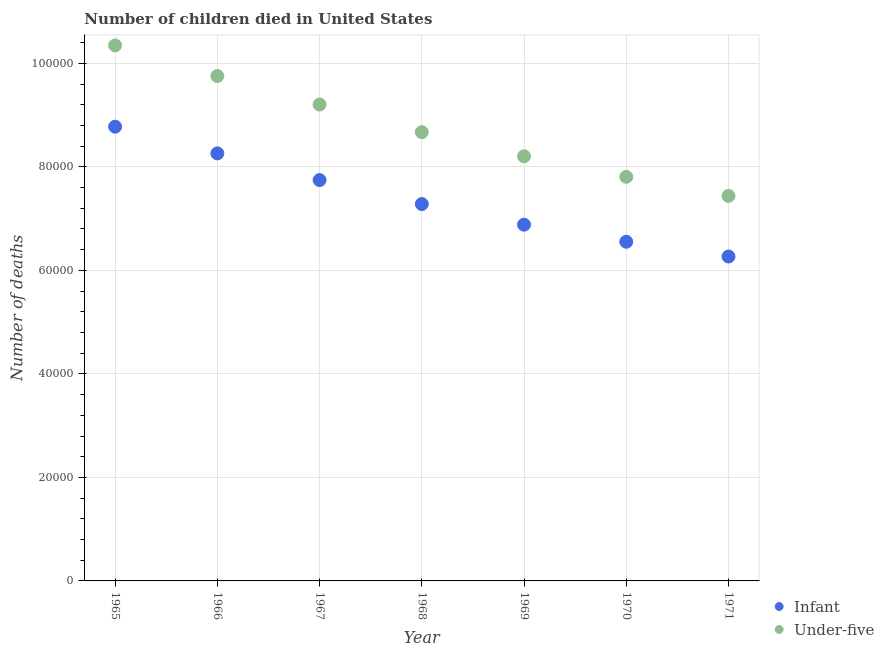What is the number of under-five deaths in 1968?
Keep it short and to the point. 8.67e+04. Across all years, what is the maximum number of infant deaths?
Offer a very short reply. 8.78e+04. Across all years, what is the minimum number of infant deaths?
Keep it short and to the point. 6.27e+04. In which year was the number of infant deaths maximum?
Give a very brief answer. 1965. What is the total number of infant deaths in the graph?
Your answer should be very brief. 5.18e+05. What is the difference between the number of infant deaths in 1965 and that in 1971?
Offer a terse response. 2.51e+04. What is the difference between the number of infant deaths in 1967 and the number of under-five deaths in 1970?
Give a very brief answer. -627. What is the average number of under-five deaths per year?
Provide a short and direct response. 8.78e+04. In the year 1968, what is the difference between the number of under-five deaths and number of infant deaths?
Provide a short and direct response. 1.39e+04. In how many years, is the number of under-five deaths greater than 68000?
Provide a short and direct response. 7. What is the ratio of the number of infant deaths in 1968 to that in 1970?
Offer a terse response. 1.11. Is the difference between the number of infant deaths in 1967 and 1968 greater than the difference between the number of under-five deaths in 1967 and 1968?
Your answer should be compact. No. What is the difference between the highest and the second highest number of infant deaths?
Provide a succinct answer. 5159. What is the difference between the highest and the lowest number of infant deaths?
Give a very brief answer. 2.51e+04. In how many years, is the number of infant deaths greater than the average number of infant deaths taken over all years?
Provide a succinct answer. 3. Is the sum of the number of under-five deaths in 1965 and 1966 greater than the maximum number of infant deaths across all years?
Provide a succinct answer. Yes. What is the difference between two consecutive major ticks on the Y-axis?
Make the answer very short. 2.00e+04. Are the values on the major ticks of Y-axis written in scientific E-notation?
Provide a succinct answer. No. Does the graph contain any zero values?
Your answer should be compact. No. How many legend labels are there?
Offer a terse response. 2. How are the legend labels stacked?
Offer a very short reply. Vertical. What is the title of the graph?
Make the answer very short. Number of children died in United States. Does "National Visitors" appear as one of the legend labels in the graph?
Give a very brief answer. No. What is the label or title of the Y-axis?
Your response must be concise. Number of deaths. What is the Number of deaths in Infant in 1965?
Offer a very short reply. 8.78e+04. What is the Number of deaths in Under-five in 1965?
Your response must be concise. 1.03e+05. What is the Number of deaths in Infant in 1966?
Ensure brevity in your answer.  8.26e+04. What is the Number of deaths of Under-five in 1966?
Your answer should be very brief. 9.75e+04. What is the Number of deaths of Infant in 1967?
Give a very brief answer. 7.74e+04. What is the Number of deaths of Under-five in 1967?
Provide a succinct answer. 9.20e+04. What is the Number of deaths in Infant in 1968?
Provide a succinct answer. 7.28e+04. What is the Number of deaths of Under-five in 1968?
Provide a short and direct response. 8.67e+04. What is the Number of deaths in Infant in 1969?
Your answer should be compact. 6.88e+04. What is the Number of deaths in Under-five in 1969?
Offer a terse response. 8.20e+04. What is the Number of deaths of Infant in 1970?
Your response must be concise. 6.55e+04. What is the Number of deaths in Under-five in 1970?
Make the answer very short. 7.81e+04. What is the Number of deaths of Infant in 1971?
Keep it short and to the point. 6.27e+04. What is the Number of deaths in Under-five in 1971?
Offer a very short reply. 7.44e+04. Across all years, what is the maximum Number of deaths of Infant?
Offer a very short reply. 8.78e+04. Across all years, what is the maximum Number of deaths in Under-five?
Ensure brevity in your answer.  1.03e+05. Across all years, what is the minimum Number of deaths in Infant?
Provide a short and direct response. 6.27e+04. Across all years, what is the minimum Number of deaths of Under-five?
Keep it short and to the point. 7.44e+04. What is the total Number of deaths of Infant in the graph?
Provide a succinct answer. 5.18e+05. What is the total Number of deaths of Under-five in the graph?
Keep it short and to the point. 6.14e+05. What is the difference between the Number of deaths of Infant in 1965 and that in 1966?
Offer a terse response. 5159. What is the difference between the Number of deaths of Under-five in 1965 and that in 1966?
Offer a terse response. 5917. What is the difference between the Number of deaths in Infant in 1965 and that in 1967?
Make the answer very short. 1.03e+04. What is the difference between the Number of deaths of Under-five in 1965 and that in 1967?
Keep it short and to the point. 1.14e+04. What is the difference between the Number of deaths in Infant in 1965 and that in 1968?
Your answer should be compact. 1.49e+04. What is the difference between the Number of deaths of Under-five in 1965 and that in 1968?
Your response must be concise. 1.68e+04. What is the difference between the Number of deaths in Infant in 1965 and that in 1969?
Your answer should be compact. 1.89e+04. What is the difference between the Number of deaths in Under-five in 1965 and that in 1969?
Provide a succinct answer. 2.14e+04. What is the difference between the Number of deaths of Infant in 1965 and that in 1970?
Keep it short and to the point. 2.22e+04. What is the difference between the Number of deaths of Under-five in 1965 and that in 1970?
Provide a succinct answer. 2.54e+04. What is the difference between the Number of deaths of Infant in 1965 and that in 1971?
Give a very brief answer. 2.51e+04. What is the difference between the Number of deaths of Under-five in 1965 and that in 1971?
Your answer should be compact. 2.91e+04. What is the difference between the Number of deaths in Infant in 1966 and that in 1967?
Provide a succinct answer. 5157. What is the difference between the Number of deaths in Under-five in 1966 and that in 1967?
Offer a terse response. 5499. What is the difference between the Number of deaths of Infant in 1966 and that in 1968?
Give a very brief answer. 9789. What is the difference between the Number of deaths of Under-five in 1966 and that in 1968?
Provide a succinct answer. 1.08e+04. What is the difference between the Number of deaths of Infant in 1966 and that in 1969?
Keep it short and to the point. 1.38e+04. What is the difference between the Number of deaths of Under-five in 1966 and that in 1969?
Your answer should be very brief. 1.55e+04. What is the difference between the Number of deaths in Infant in 1966 and that in 1970?
Your answer should be compact. 1.71e+04. What is the difference between the Number of deaths of Under-five in 1966 and that in 1970?
Provide a short and direct response. 1.95e+04. What is the difference between the Number of deaths in Infant in 1966 and that in 1971?
Provide a succinct answer. 1.99e+04. What is the difference between the Number of deaths in Under-five in 1966 and that in 1971?
Provide a short and direct response. 2.32e+04. What is the difference between the Number of deaths in Infant in 1967 and that in 1968?
Offer a terse response. 4632. What is the difference between the Number of deaths in Under-five in 1967 and that in 1968?
Offer a very short reply. 5339. What is the difference between the Number of deaths in Infant in 1967 and that in 1969?
Offer a terse response. 8618. What is the difference between the Number of deaths in Under-five in 1967 and that in 1969?
Your answer should be compact. 1.00e+04. What is the difference between the Number of deaths in Infant in 1967 and that in 1970?
Give a very brief answer. 1.19e+04. What is the difference between the Number of deaths in Under-five in 1967 and that in 1970?
Offer a very short reply. 1.40e+04. What is the difference between the Number of deaths in Infant in 1967 and that in 1971?
Ensure brevity in your answer.  1.48e+04. What is the difference between the Number of deaths in Under-five in 1967 and that in 1971?
Provide a succinct answer. 1.77e+04. What is the difference between the Number of deaths in Infant in 1968 and that in 1969?
Your answer should be very brief. 3986. What is the difference between the Number of deaths in Under-five in 1968 and that in 1969?
Make the answer very short. 4663. What is the difference between the Number of deaths of Infant in 1968 and that in 1970?
Provide a short and direct response. 7285. What is the difference between the Number of deaths of Under-five in 1968 and that in 1970?
Your response must be concise. 8634. What is the difference between the Number of deaths of Infant in 1968 and that in 1971?
Your response must be concise. 1.01e+04. What is the difference between the Number of deaths in Under-five in 1968 and that in 1971?
Provide a short and direct response. 1.23e+04. What is the difference between the Number of deaths in Infant in 1969 and that in 1970?
Give a very brief answer. 3299. What is the difference between the Number of deaths in Under-five in 1969 and that in 1970?
Keep it short and to the point. 3971. What is the difference between the Number of deaths in Infant in 1969 and that in 1971?
Provide a succinct answer. 6153. What is the difference between the Number of deaths in Under-five in 1969 and that in 1971?
Give a very brief answer. 7653. What is the difference between the Number of deaths of Infant in 1970 and that in 1971?
Offer a terse response. 2854. What is the difference between the Number of deaths of Under-five in 1970 and that in 1971?
Offer a terse response. 3682. What is the difference between the Number of deaths in Infant in 1965 and the Number of deaths in Under-five in 1966?
Make the answer very short. -9783. What is the difference between the Number of deaths in Infant in 1965 and the Number of deaths in Under-five in 1967?
Provide a short and direct response. -4284. What is the difference between the Number of deaths of Infant in 1965 and the Number of deaths of Under-five in 1968?
Your response must be concise. 1055. What is the difference between the Number of deaths in Infant in 1965 and the Number of deaths in Under-five in 1969?
Offer a very short reply. 5718. What is the difference between the Number of deaths in Infant in 1965 and the Number of deaths in Under-five in 1970?
Keep it short and to the point. 9689. What is the difference between the Number of deaths of Infant in 1965 and the Number of deaths of Under-five in 1971?
Give a very brief answer. 1.34e+04. What is the difference between the Number of deaths in Infant in 1966 and the Number of deaths in Under-five in 1967?
Provide a short and direct response. -9443. What is the difference between the Number of deaths of Infant in 1966 and the Number of deaths of Under-five in 1968?
Keep it short and to the point. -4104. What is the difference between the Number of deaths of Infant in 1966 and the Number of deaths of Under-five in 1969?
Your answer should be very brief. 559. What is the difference between the Number of deaths in Infant in 1966 and the Number of deaths in Under-five in 1970?
Your answer should be very brief. 4530. What is the difference between the Number of deaths in Infant in 1966 and the Number of deaths in Under-five in 1971?
Give a very brief answer. 8212. What is the difference between the Number of deaths of Infant in 1967 and the Number of deaths of Under-five in 1968?
Offer a very short reply. -9261. What is the difference between the Number of deaths of Infant in 1967 and the Number of deaths of Under-five in 1969?
Provide a succinct answer. -4598. What is the difference between the Number of deaths of Infant in 1967 and the Number of deaths of Under-five in 1970?
Make the answer very short. -627. What is the difference between the Number of deaths of Infant in 1967 and the Number of deaths of Under-five in 1971?
Your answer should be very brief. 3055. What is the difference between the Number of deaths in Infant in 1968 and the Number of deaths in Under-five in 1969?
Keep it short and to the point. -9230. What is the difference between the Number of deaths of Infant in 1968 and the Number of deaths of Under-five in 1970?
Ensure brevity in your answer.  -5259. What is the difference between the Number of deaths of Infant in 1968 and the Number of deaths of Under-five in 1971?
Give a very brief answer. -1577. What is the difference between the Number of deaths of Infant in 1969 and the Number of deaths of Under-five in 1970?
Your answer should be compact. -9245. What is the difference between the Number of deaths of Infant in 1969 and the Number of deaths of Under-five in 1971?
Provide a short and direct response. -5563. What is the difference between the Number of deaths of Infant in 1970 and the Number of deaths of Under-five in 1971?
Ensure brevity in your answer.  -8862. What is the average Number of deaths of Infant per year?
Your answer should be very brief. 7.40e+04. What is the average Number of deaths in Under-five per year?
Provide a short and direct response. 8.78e+04. In the year 1965, what is the difference between the Number of deaths of Infant and Number of deaths of Under-five?
Keep it short and to the point. -1.57e+04. In the year 1966, what is the difference between the Number of deaths of Infant and Number of deaths of Under-five?
Give a very brief answer. -1.49e+04. In the year 1967, what is the difference between the Number of deaths in Infant and Number of deaths in Under-five?
Your response must be concise. -1.46e+04. In the year 1968, what is the difference between the Number of deaths in Infant and Number of deaths in Under-five?
Offer a terse response. -1.39e+04. In the year 1969, what is the difference between the Number of deaths of Infant and Number of deaths of Under-five?
Provide a short and direct response. -1.32e+04. In the year 1970, what is the difference between the Number of deaths in Infant and Number of deaths in Under-five?
Make the answer very short. -1.25e+04. In the year 1971, what is the difference between the Number of deaths of Infant and Number of deaths of Under-five?
Your answer should be very brief. -1.17e+04. What is the ratio of the Number of deaths of Infant in 1965 to that in 1966?
Keep it short and to the point. 1.06. What is the ratio of the Number of deaths in Under-five in 1965 to that in 1966?
Ensure brevity in your answer.  1.06. What is the ratio of the Number of deaths of Infant in 1965 to that in 1967?
Provide a succinct answer. 1.13. What is the ratio of the Number of deaths in Under-five in 1965 to that in 1967?
Give a very brief answer. 1.12. What is the ratio of the Number of deaths in Infant in 1965 to that in 1968?
Make the answer very short. 1.21. What is the ratio of the Number of deaths of Under-five in 1965 to that in 1968?
Give a very brief answer. 1.19. What is the ratio of the Number of deaths in Infant in 1965 to that in 1969?
Your answer should be very brief. 1.28. What is the ratio of the Number of deaths in Under-five in 1965 to that in 1969?
Offer a very short reply. 1.26. What is the ratio of the Number of deaths in Infant in 1965 to that in 1970?
Your answer should be very brief. 1.34. What is the ratio of the Number of deaths in Under-five in 1965 to that in 1970?
Ensure brevity in your answer.  1.33. What is the ratio of the Number of deaths of Infant in 1965 to that in 1971?
Ensure brevity in your answer.  1.4. What is the ratio of the Number of deaths in Under-five in 1965 to that in 1971?
Provide a short and direct response. 1.39. What is the ratio of the Number of deaths in Infant in 1966 to that in 1967?
Your answer should be compact. 1.07. What is the ratio of the Number of deaths of Under-five in 1966 to that in 1967?
Ensure brevity in your answer.  1.06. What is the ratio of the Number of deaths of Infant in 1966 to that in 1968?
Your answer should be compact. 1.13. What is the ratio of the Number of deaths in Infant in 1966 to that in 1969?
Make the answer very short. 1.2. What is the ratio of the Number of deaths in Under-five in 1966 to that in 1969?
Offer a very short reply. 1.19. What is the ratio of the Number of deaths in Infant in 1966 to that in 1970?
Your answer should be compact. 1.26. What is the ratio of the Number of deaths of Under-five in 1966 to that in 1970?
Ensure brevity in your answer.  1.25. What is the ratio of the Number of deaths in Infant in 1966 to that in 1971?
Give a very brief answer. 1.32. What is the ratio of the Number of deaths of Under-five in 1966 to that in 1971?
Provide a short and direct response. 1.31. What is the ratio of the Number of deaths in Infant in 1967 to that in 1968?
Ensure brevity in your answer.  1.06. What is the ratio of the Number of deaths of Under-five in 1967 to that in 1968?
Keep it short and to the point. 1.06. What is the ratio of the Number of deaths in Infant in 1967 to that in 1969?
Give a very brief answer. 1.13. What is the ratio of the Number of deaths of Under-five in 1967 to that in 1969?
Your response must be concise. 1.12. What is the ratio of the Number of deaths of Infant in 1967 to that in 1970?
Provide a short and direct response. 1.18. What is the ratio of the Number of deaths in Under-five in 1967 to that in 1970?
Make the answer very short. 1.18. What is the ratio of the Number of deaths of Infant in 1967 to that in 1971?
Offer a very short reply. 1.24. What is the ratio of the Number of deaths of Under-five in 1967 to that in 1971?
Your answer should be compact. 1.24. What is the ratio of the Number of deaths in Infant in 1968 to that in 1969?
Your response must be concise. 1.06. What is the ratio of the Number of deaths in Under-five in 1968 to that in 1969?
Make the answer very short. 1.06. What is the ratio of the Number of deaths in Infant in 1968 to that in 1970?
Offer a very short reply. 1.11. What is the ratio of the Number of deaths in Under-five in 1968 to that in 1970?
Your answer should be very brief. 1.11. What is the ratio of the Number of deaths of Infant in 1968 to that in 1971?
Your answer should be compact. 1.16. What is the ratio of the Number of deaths of Under-five in 1968 to that in 1971?
Give a very brief answer. 1.17. What is the ratio of the Number of deaths in Infant in 1969 to that in 1970?
Provide a succinct answer. 1.05. What is the ratio of the Number of deaths of Under-five in 1969 to that in 1970?
Provide a succinct answer. 1.05. What is the ratio of the Number of deaths in Infant in 1969 to that in 1971?
Make the answer very short. 1.1. What is the ratio of the Number of deaths in Under-five in 1969 to that in 1971?
Your answer should be very brief. 1.1. What is the ratio of the Number of deaths of Infant in 1970 to that in 1971?
Your response must be concise. 1.05. What is the ratio of the Number of deaths of Under-five in 1970 to that in 1971?
Keep it short and to the point. 1.05. What is the difference between the highest and the second highest Number of deaths in Infant?
Keep it short and to the point. 5159. What is the difference between the highest and the second highest Number of deaths of Under-five?
Offer a very short reply. 5917. What is the difference between the highest and the lowest Number of deaths of Infant?
Provide a succinct answer. 2.51e+04. What is the difference between the highest and the lowest Number of deaths in Under-five?
Keep it short and to the point. 2.91e+04. 